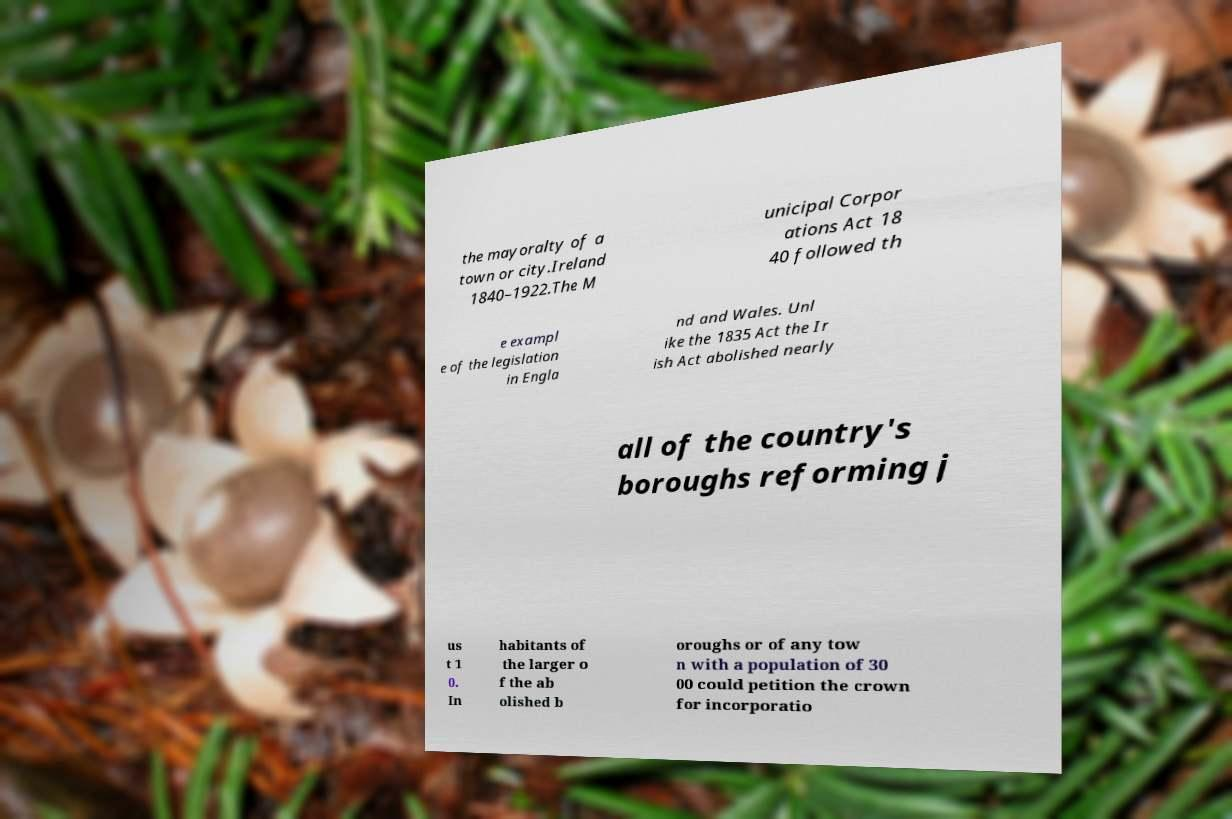Could you assist in decoding the text presented in this image and type it out clearly? the mayoralty of a town or city.Ireland 1840–1922.The M unicipal Corpor ations Act 18 40 followed th e exampl e of the legislation in Engla nd and Wales. Unl ike the 1835 Act the Ir ish Act abolished nearly all of the country's boroughs reforming j us t 1 0. In habitants of the larger o f the ab olished b oroughs or of any tow n with a population of 30 00 could petition the crown for incorporatio 